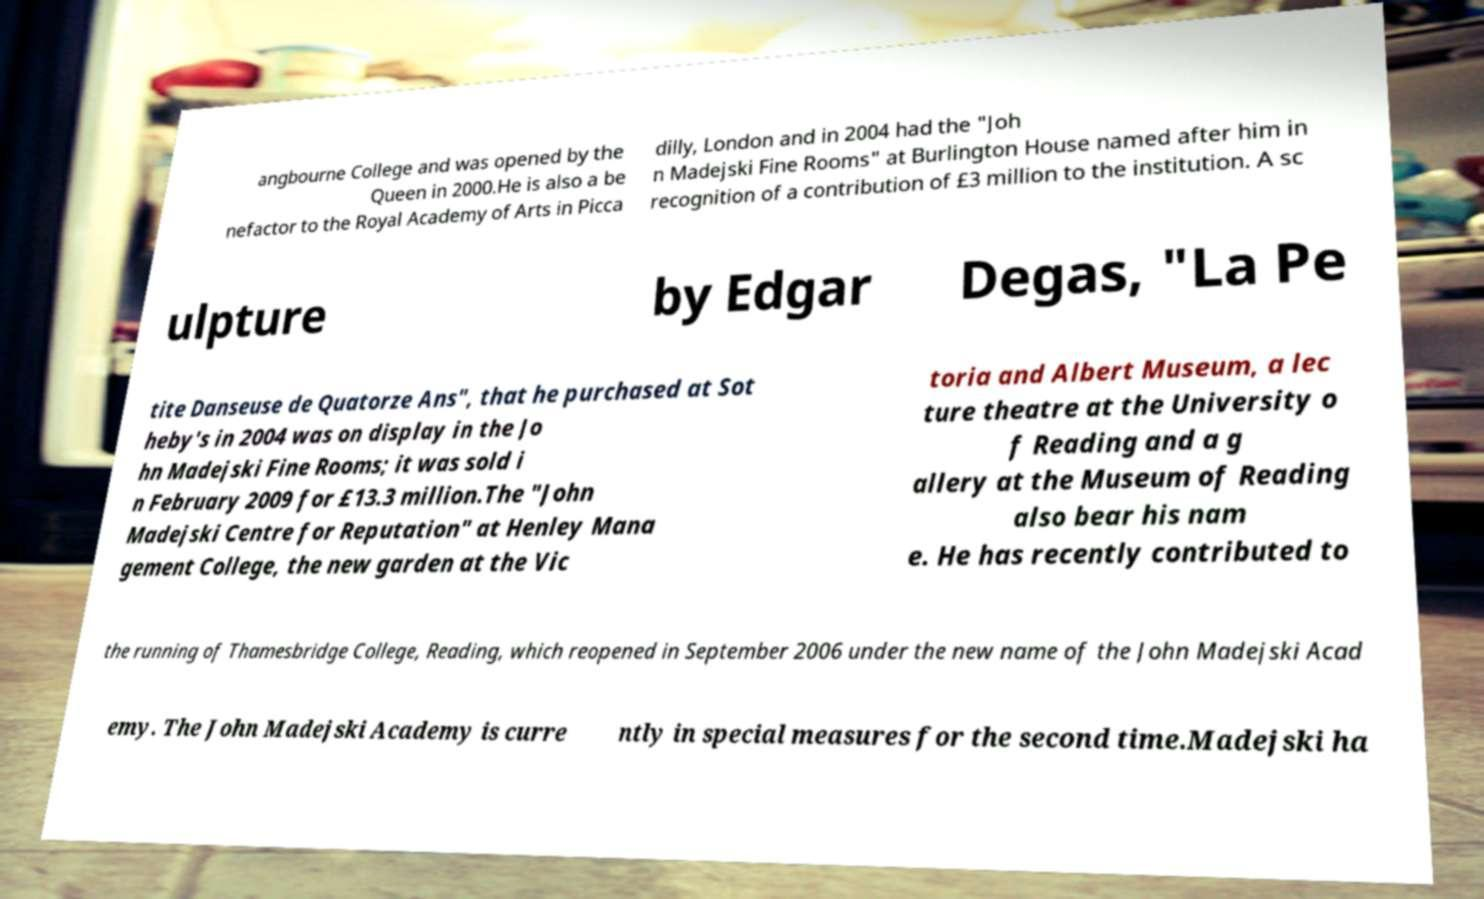For documentation purposes, I need the text within this image transcribed. Could you provide that? angbourne College and was opened by the Queen in 2000.He is also a be nefactor to the Royal Academy of Arts in Picca dilly, London and in 2004 had the "Joh n Madejski Fine Rooms" at Burlington House named after him in recognition of a contribution of £3 million to the institution. A sc ulpture by Edgar Degas, "La Pe tite Danseuse de Quatorze Ans", that he purchased at Sot heby's in 2004 was on display in the Jo hn Madejski Fine Rooms; it was sold i n February 2009 for £13.3 million.The "John Madejski Centre for Reputation" at Henley Mana gement College, the new garden at the Vic toria and Albert Museum, a lec ture theatre at the University o f Reading and a g allery at the Museum of Reading also bear his nam e. He has recently contributed to the running of Thamesbridge College, Reading, which reopened in September 2006 under the new name of the John Madejski Acad emy. The John Madejski Academy is curre ntly in special measures for the second time.Madejski ha 